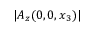<formula> <loc_0><loc_0><loc_500><loc_500>| A _ { z } ( 0 , 0 , x _ { 3 } ) |</formula> 